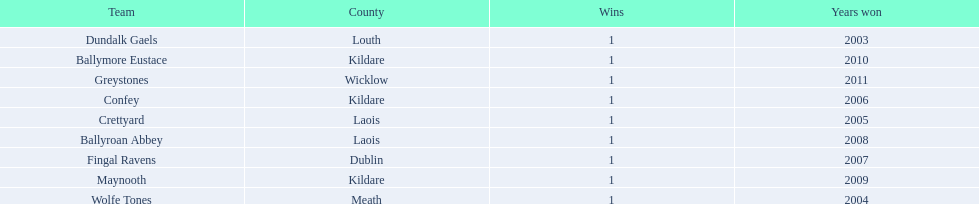Which county had the most number of wins? Kildare. 